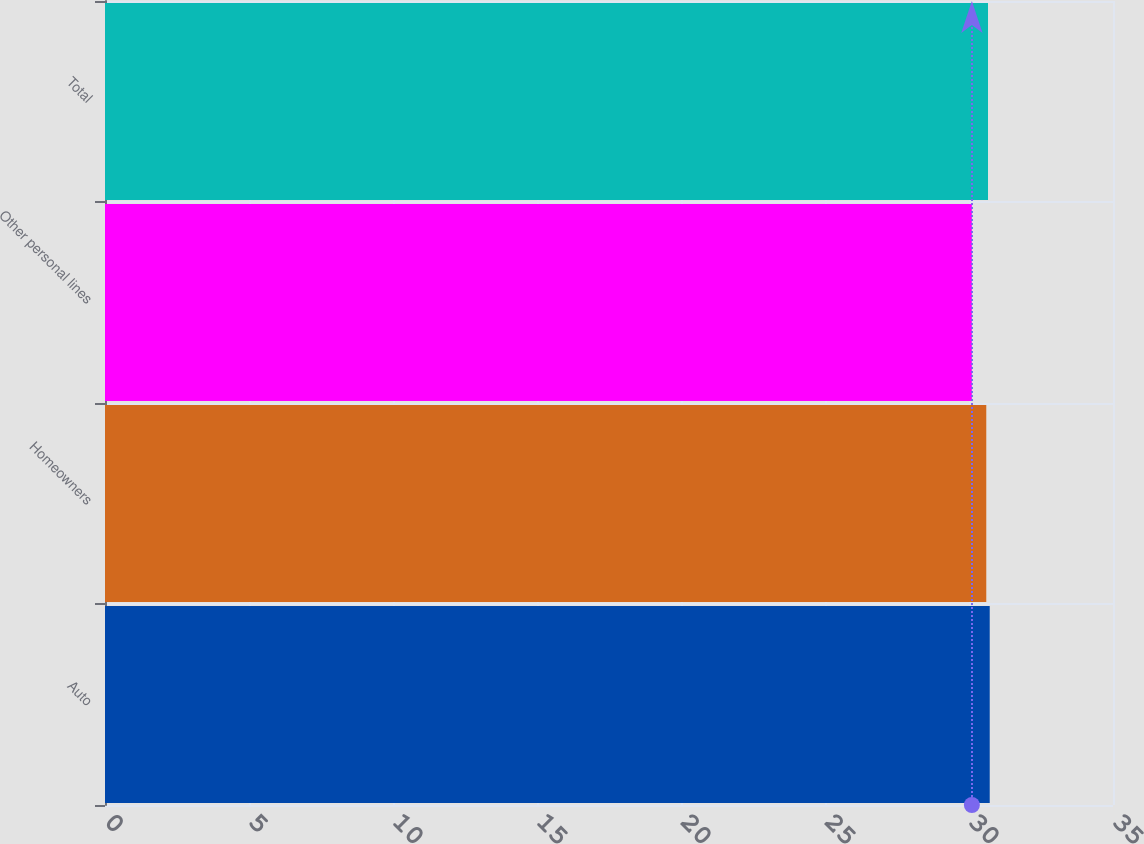<chart> <loc_0><loc_0><loc_500><loc_500><bar_chart><fcel>Auto<fcel>Homeowners<fcel>Other personal lines<fcel>Total<nl><fcel>30.72<fcel>30.6<fcel>30.1<fcel>30.66<nl></chart> 